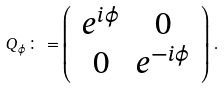Convert formula to latex. <formula><loc_0><loc_0><loc_500><loc_500>Q _ { \phi } \colon = \left ( \, \begin{array} { c c } e ^ { i \phi } & 0 \\ 0 & e ^ { - i \phi } \\ \end{array} \, \right ) \, .</formula> 